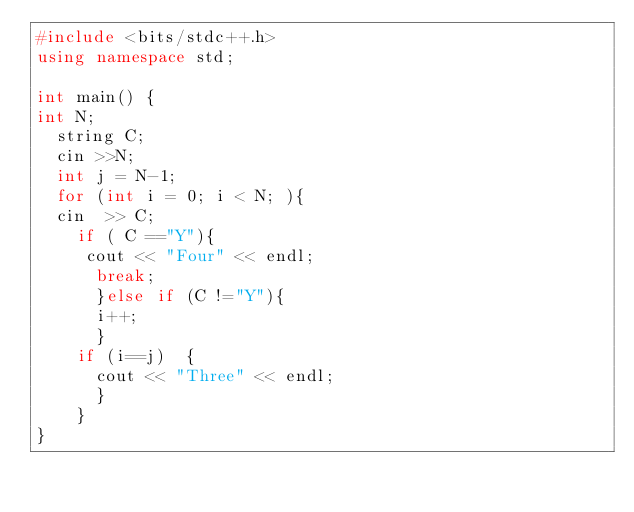Convert code to text. <code><loc_0><loc_0><loc_500><loc_500><_C++_>#include <bits/stdc++.h>
using namespace std;

int main() {
int N;
  string C;
  cin >>N;
  int j = N-1;
  for (int i = 0; i < N; ){
  cin  >> C;
    if ( C =="Y"){
     cout << "Four" << endl; 
      break;
      }else if (C !="Y"){
      i++;
      }
    if (i==j)  {
      cout << "Three" << endl;
      }
    }
}
</code> 